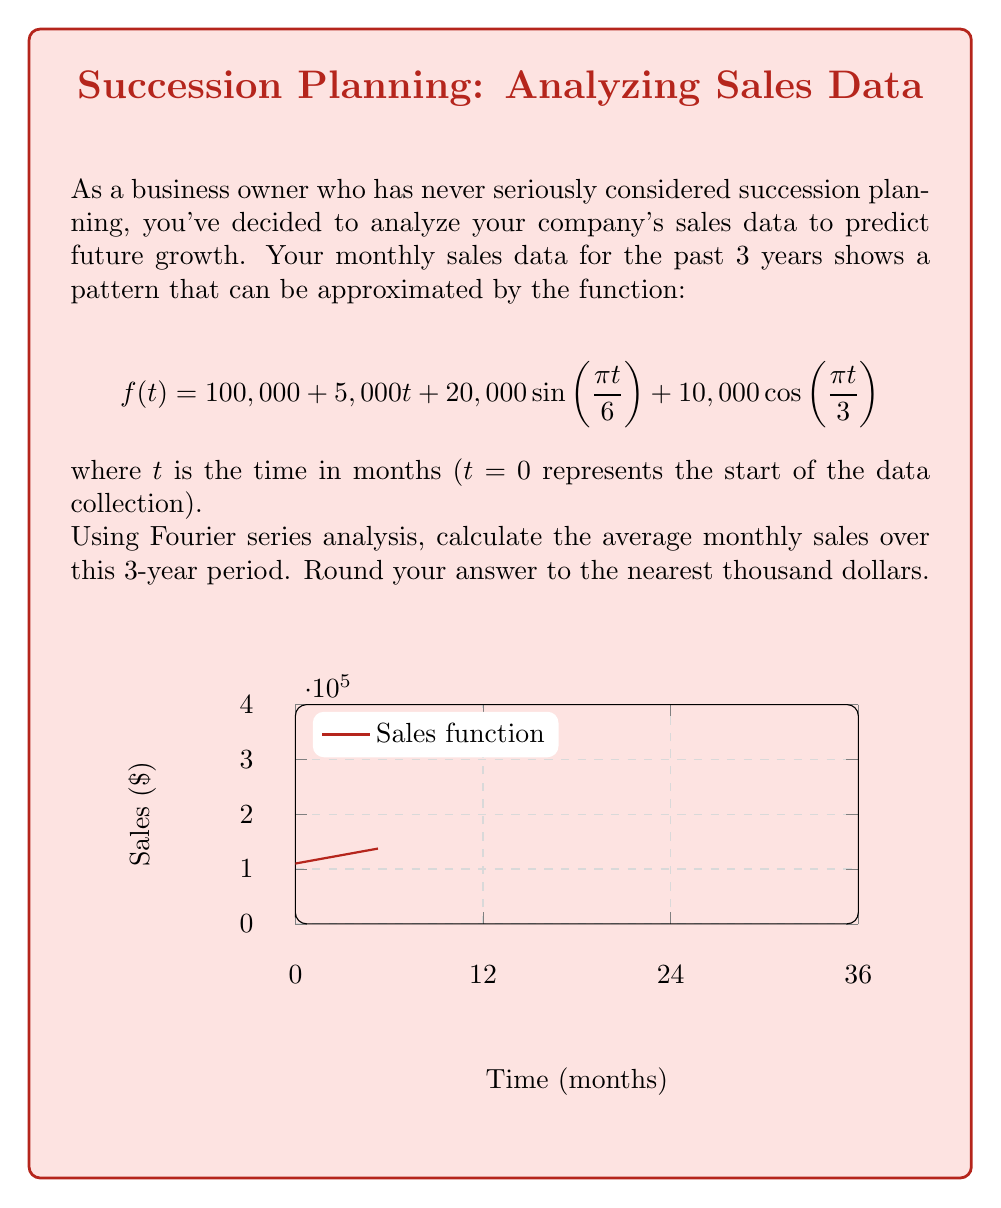What is the answer to this math problem? To solve this problem, we'll use the key property of Fourier series that the average value of a function over its period is equal to the constant term (a₀) in its Fourier series expansion.

Step 1: Identify the components of the function.
$$f(t) = 100,000 + 5,000t + 20,000\sin(\frac{\pi t}{6}) + 10,000\cos(\frac{\pi t}{3})$$

Step 2: Determine the period of the function.
The period is the least common multiple of the periods of the sine and cosine terms:
LCM(12, 6) = 12 months

Step 3: Calculate the average value over the period.
The average value is given by:

$$\frac{1}{T}\int_0^T f(t) dt$$

where T is the period (12 months).

$$\frac{1}{12}\int_0^{12} (100,000 + 5,000t + 20,000\sin(\frac{\pi t}{6}) + 10,000\cos(\frac{\pi t}{3})) dt$$

Step 4: Integrate each term separately.

a) Constant term: $\frac{1}{12}\int_0^{12} 100,000 dt = 100,000$

b) Linear term: $\frac{1}{12}\int_0^{12} 5,000t dt = \frac{5,000}{12} \cdot \frac{12^2}{2} = 30,000$

c) Sine term: $\frac{1}{12}\int_0^{12} 20,000\sin(\frac{\pi t}{6}) dt = 0$ (integrates to 0 over a full period)

d) Cosine term: $\frac{1}{12}\int_0^{12} 10,000\cos(\frac{\pi t}{3}) dt = 0$ (integrates to 0 over a full period)

Step 5: Sum the results.
Average monthly sales = 100,000 + 30,000 = 130,000

Step 6: Round to the nearest thousand.
130,000 rounds to 130,000.
Answer: $130,000 